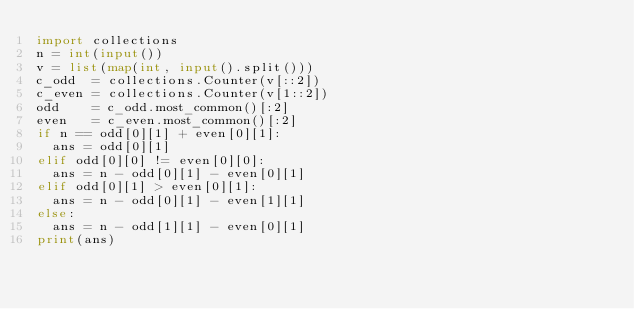Convert code to text. <code><loc_0><loc_0><loc_500><loc_500><_Python_>import collections
n = int(input())
v = list(map(int, input().split()))
c_odd  = collections.Counter(v[::2])
c_even = collections.Counter(v[1::2])
odd    = c_odd.most_common()[:2]
even   = c_even.most_common()[:2]
if n == odd[0][1] + even[0][1]:
	ans = odd[0][1]
elif odd[0][0] != even[0][0]:
	ans = n - odd[0][1] - even[0][1]
elif odd[0][1] > even[0][1]:
	ans = n - odd[0][1] - even[1][1]
else:
	ans = n - odd[1][1] - even[0][1]
print(ans)</code> 